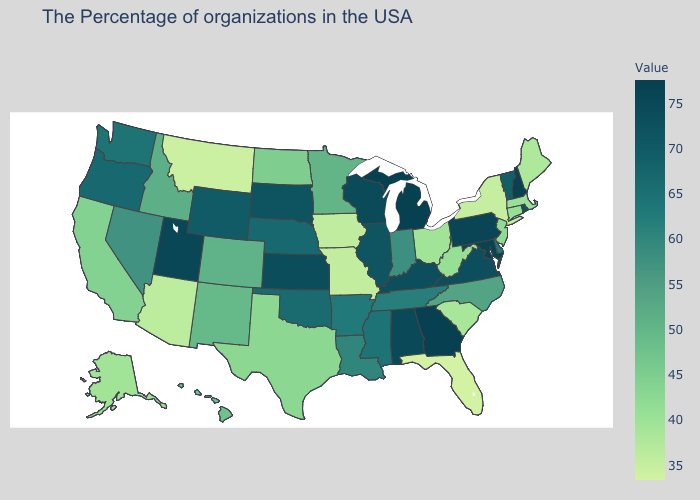Does Massachusetts have the highest value in the USA?
Quick response, please. No. Does the map have missing data?
Be succinct. No. Does Delaware have a higher value than Wyoming?
Keep it brief. No. Does Wyoming have a lower value than Indiana?
Short answer required. No. Does California have the highest value in the USA?
Quick response, please. No. Which states have the highest value in the USA?
Answer briefly. Georgia. Does New Hampshire have a higher value than New York?
Keep it brief. Yes. Among the states that border Florida , which have the highest value?
Be succinct. Georgia. 